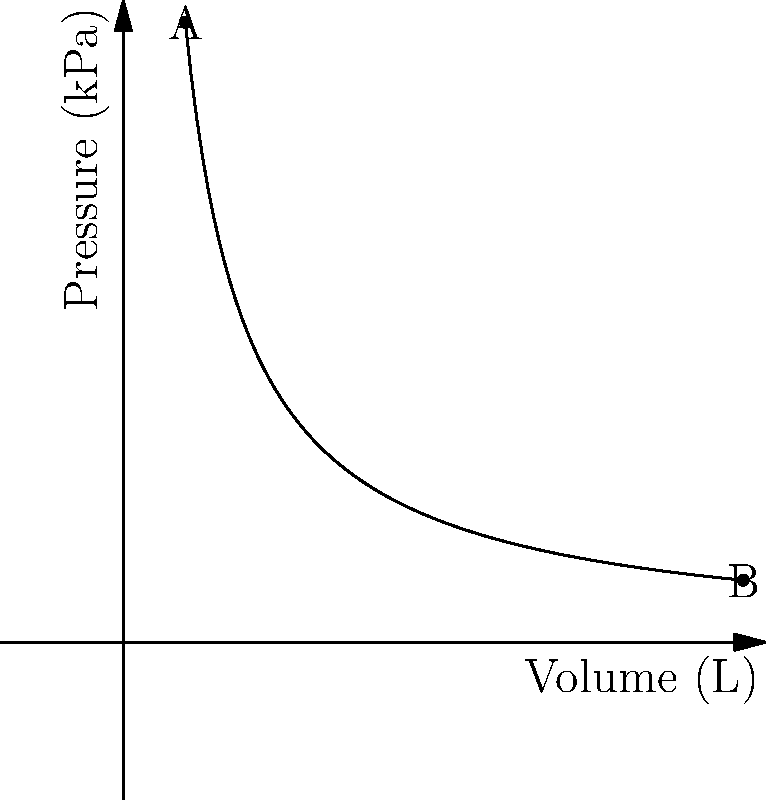As a scientific researcher working with gas suppliers, you're analyzing a pressure-volume curve for an ideal gas undergoing an isothermal process at 300 K. The curve shows two points: A (10 L, 100 kPa) and B (100 L, 10 kPa). Calculate the work done by the gas as it expands from A to B. To solve this problem, we'll follow these steps:

1) For an isothermal process of an ideal gas, we use the equation:
   $PV = constant$

2) We can verify this using the given points:
   At A: $100 \times 10 = 1000$
   At B: $10 \times 100 = 1000$

3) The work done in an isothermal expansion is given by:
   $W = nRT \ln(\frac{V_2}{V_1})$

4) We need to find $n$ (number of moles) using the ideal gas equation:
   $PV = nRT$
   $100 \times 10^3 \times 10 \times 10^{-3} = n \times 8.314 \times 300$
   $n = \frac{1000}{8.314 \times 300} = 0.4013$ mol

5) Now we can calculate the work:
   $W = 0.4013 \times 8.314 \times 300 \times \ln(\frac{100}{10})$
   $W = 0.4013 \times 8.314 \times 300 \times \ln(10)$
   $W = 0.4013 \times 8.314 \times 300 \times 2.303$
   $W = 2303$ J

6) Convert to kJ:
   $W = 2.303$ kJ

Therefore, the work done by the gas as it expands from A to B is 2.303 kJ.
Answer: 2.303 kJ 